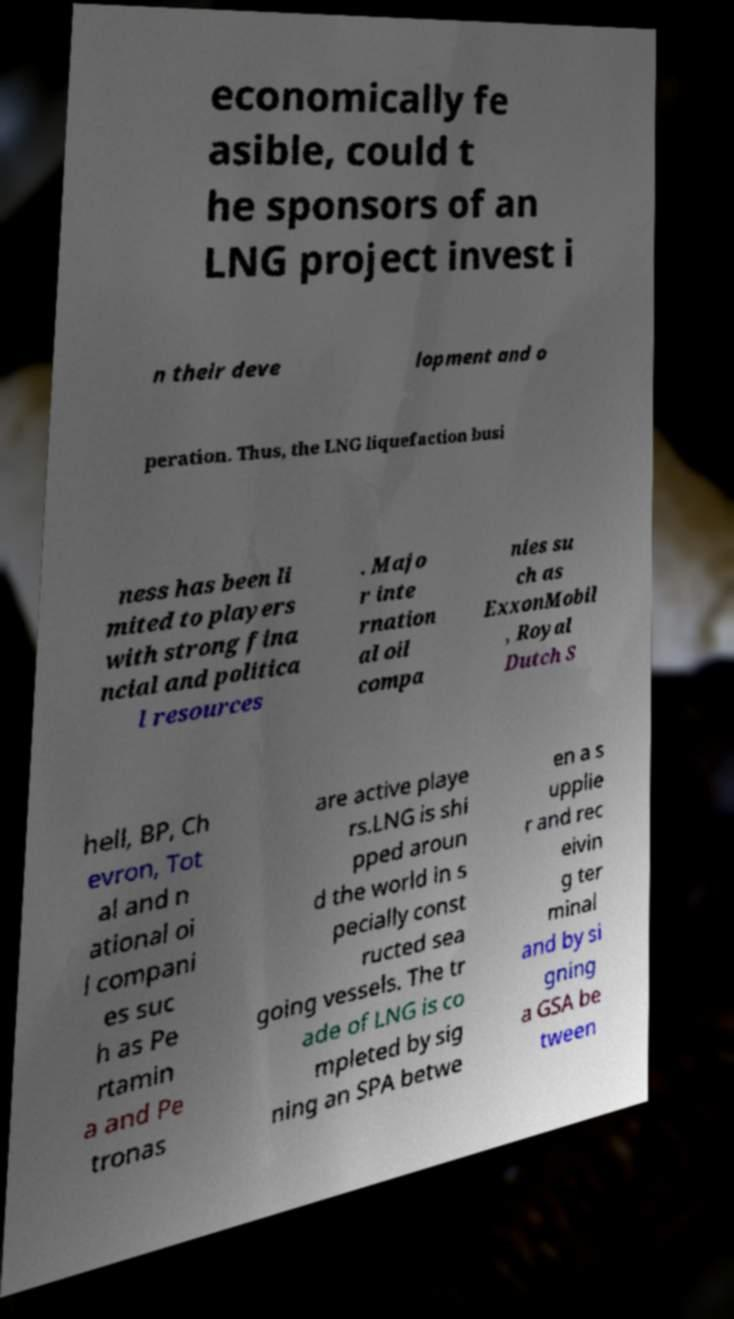What messages or text are displayed in this image? I need them in a readable, typed format. economically fe asible, could t he sponsors of an LNG project invest i n their deve lopment and o peration. Thus, the LNG liquefaction busi ness has been li mited to players with strong fina ncial and politica l resources . Majo r inte rnation al oil compa nies su ch as ExxonMobil , Royal Dutch S hell, BP, Ch evron, Tot al and n ational oi l compani es suc h as Pe rtamin a and Pe tronas are active playe rs.LNG is shi pped aroun d the world in s pecially const ructed sea going vessels. The tr ade of LNG is co mpleted by sig ning an SPA betwe en a s upplie r and rec eivin g ter minal and by si gning a GSA be tween 